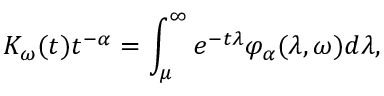Convert formula to latex. <formula><loc_0><loc_0><loc_500><loc_500>K _ { \omega } ( t ) t ^ { - \alpha } = \int _ { \mu } ^ { \infty } e ^ { - t \lambda } \varphi _ { \alpha } ( \lambda , \omega ) d \lambda ,</formula> 